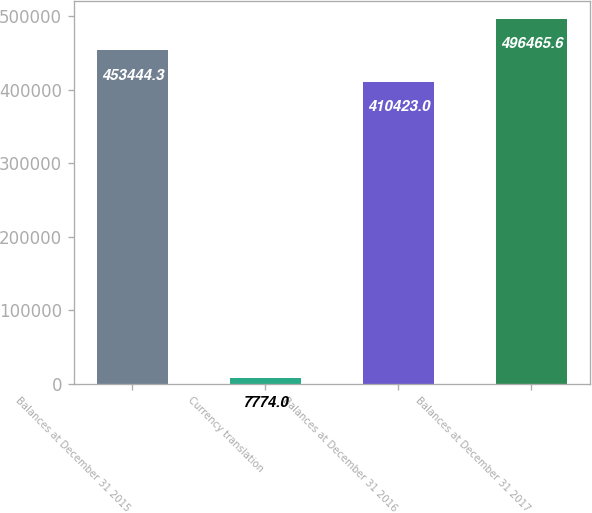Convert chart to OTSL. <chart><loc_0><loc_0><loc_500><loc_500><bar_chart><fcel>Balances at December 31 2015<fcel>Currency translation<fcel>Balances at December 31 2016<fcel>Balances at December 31 2017<nl><fcel>453444<fcel>7774<fcel>410423<fcel>496466<nl></chart> 